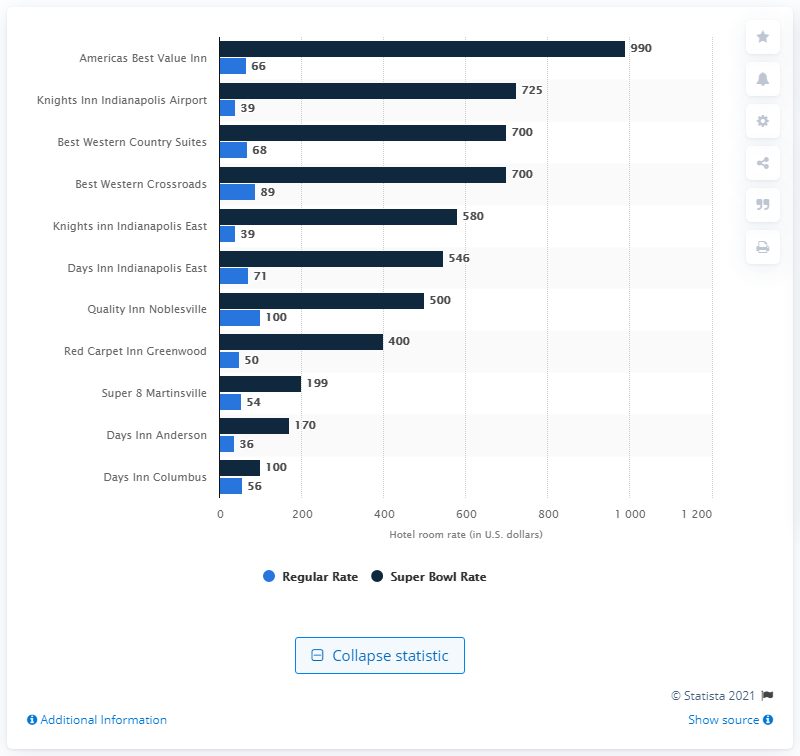Give some essential details in this illustration. The regular room rate at The Americas Best Value Inn is $66... The room rate for the Super Bowl XLVI was 990. 